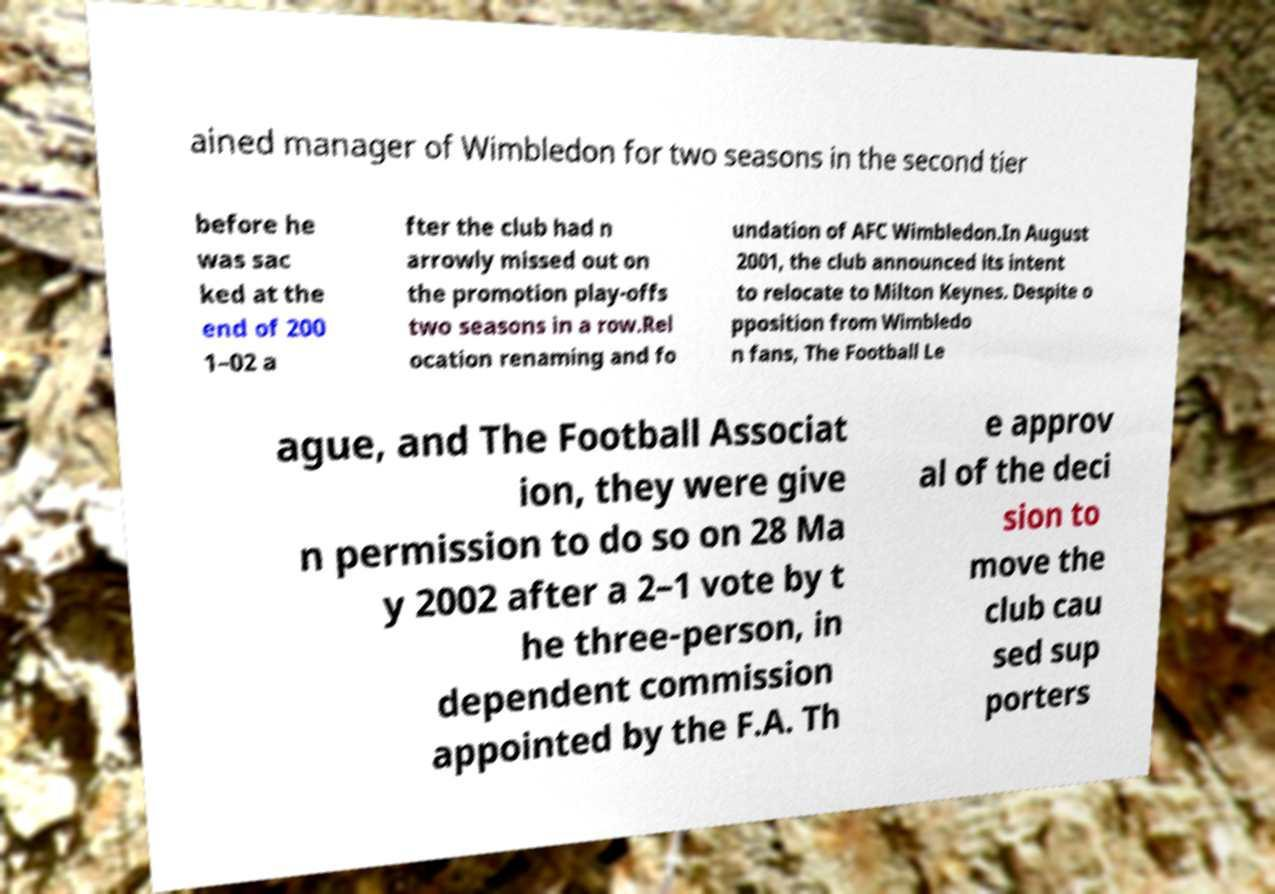Please identify and transcribe the text found in this image. ained manager of Wimbledon for two seasons in the second tier before he was sac ked at the end of 200 1–02 a fter the club had n arrowly missed out on the promotion play-offs two seasons in a row.Rel ocation renaming and fo undation of AFC Wimbledon.In August 2001, the club announced its intent to relocate to Milton Keynes. Despite o pposition from Wimbledo n fans, The Football Le ague, and The Football Associat ion, they were give n permission to do so on 28 Ma y 2002 after a 2–1 vote by t he three-person, in dependent commission appointed by the F.A. Th e approv al of the deci sion to move the club cau sed sup porters 